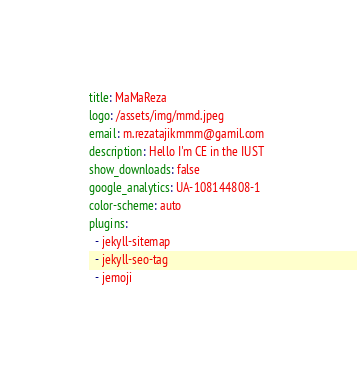<code> <loc_0><loc_0><loc_500><loc_500><_YAML_>title: MaMaReza
logo: /assets/img/mmd.jpeg
email: m.rezatajikmmm@gamil.com
description: Hello I'm CE in the IUST 
show_downloads: false
google_analytics: UA-108144808-1
color-scheme: auto
plugins:
  - jekyll-sitemap
  - jekyll-seo-tag
  - jemoji
</code> 